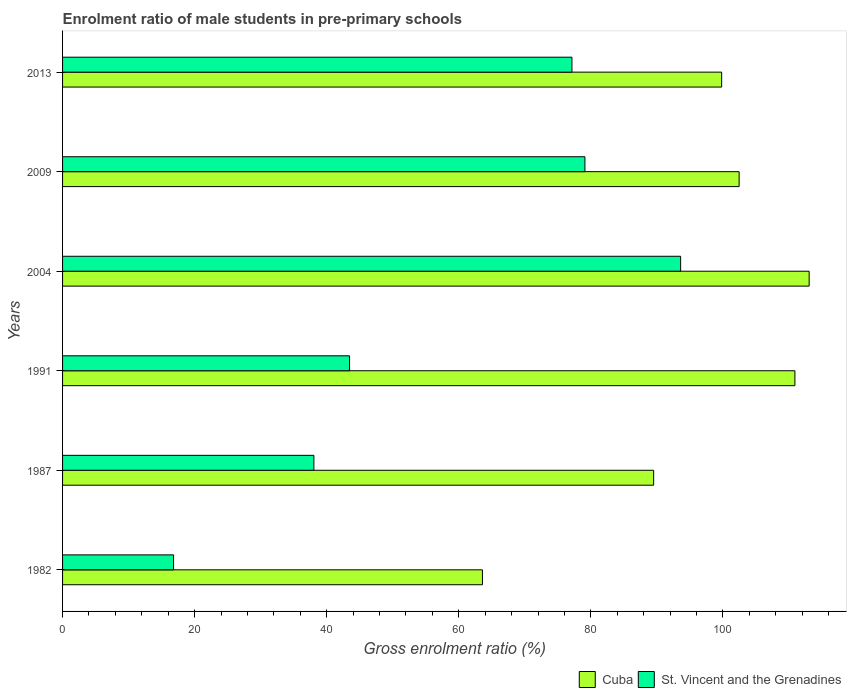How many different coloured bars are there?
Your answer should be very brief. 2. Are the number of bars per tick equal to the number of legend labels?
Offer a very short reply. Yes. Are the number of bars on each tick of the Y-axis equal?
Make the answer very short. Yes. How many bars are there on the 5th tick from the bottom?
Ensure brevity in your answer.  2. What is the label of the 3rd group of bars from the top?
Your response must be concise. 2004. What is the enrolment ratio of male students in pre-primary schools in St. Vincent and the Grenadines in 2013?
Offer a very short reply. 77.13. Across all years, what is the maximum enrolment ratio of male students in pre-primary schools in Cuba?
Ensure brevity in your answer.  113.05. Across all years, what is the minimum enrolment ratio of male students in pre-primary schools in St. Vincent and the Grenadines?
Offer a terse response. 16.81. What is the total enrolment ratio of male students in pre-primary schools in Cuba in the graph?
Give a very brief answer. 579.28. What is the difference between the enrolment ratio of male students in pre-primary schools in Cuba in 1982 and that in 2013?
Your response must be concise. -36.22. What is the difference between the enrolment ratio of male students in pre-primary schools in Cuba in 1991 and the enrolment ratio of male students in pre-primary schools in St. Vincent and the Grenadines in 2013?
Make the answer very short. 33.76. What is the average enrolment ratio of male students in pre-primary schools in St. Vincent and the Grenadines per year?
Offer a terse response. 58.02. In the year 1987, what is the difference between the enrolment ratio of male students in pre-primary schools in Cuba and enrolment ratio of male students in pre-primary schools in St. Vincent and the Grenadines?
Keep it short and to the point. 51.45. In how many years, is the enrolment ratio of male students in pre-primary schools in St. Vincent and the Grenadines greater than 28 %?
Offer a terse response. 5. What is the ratio of the enrolment ratio of male students in pre-primary schools in St. Vincent and the Grenadines in 1991 to that in 2013?
Keep it short and to the point. 0.56. Is the enrolment ratio of male students in pre-primary schools in St. Vincent and the Grenadines in 2004 less than that in 2013?
Provide a short and direct response. No. What is the difference between the highest and the second highest enrolment ratio of male students in pre-primary schools in St. Vincent and the Grenadines?
Keep it short and to the point. 14.49. What is the difference between the highest and the lowest enrolment ratio of male students in pre-primary schools in Cuba?
Keep it short and to the point. 49.47. In how many years, is the enrolment ratio of male students in pre-primary schools in St. Vincent and the Grenadines greater than the average enrolment ratio of male students in pre-primary schools in St. Vincent and the Grenadines taken over all years?
Your response must be concise. 3. Is the sum of the enrolment ratio of male students in pre-primary schools in Cuba in 1982 and 2013 greater than the maximum enrolment ratio of male students in pre-primary schools in St. Vincent and the Grenadines across all years?
Ensure brevity in your answer.  Yes. What does the 1st bar from the top in 2004 represents?
Provide a succinct answer. St. Vincent and the Grenadines. What does the 1st bar from the bottom in 2004 represents?
Offer a terse response. Cuba. Are all the bars in the graph horizontal?
Ensure brevity in your answer.  Yes. How many years are there in the graph?
Your answer should be very brief. 6. Does the graph contain any zero values?
Make the answer very short. No. Where does the legend appear in the graph?
Ensure brevity in your answer.  Bottom right. How many legend labels are there?
Your answer should be compact. 2. How are the legend labels stacked?
Provide a succinct answer. Horizontal. What is the title of the graph?
Provide a short and direct response. Enrolment ratio of male students in pre-primary schools. Does "United Arab Emirates" appear as one of the legend labels in the graph?
Your answer should be compact. No. What is the Gross enrolment ratio (%) of Cuba in 1982?
Offer a very short reply. 63.58. What is the Gross enrolment ratio (%) of St. Vincent and the Grenadines in 1982?
Ensure brevity in your answer.  16.81. What is the Gross enrolment ratio (%) of Cuba in 1987?
Offer a very short reply. 89.51. What is the Gross enrolment ratio (%) of St. Vincent and the Grenadines in 1987?
Give a very brief answer. 38.06. What is the Gross enrolment ratio (%) of Cuba in 1991?
Your answer should be compact. 110.89. What is the Gross enrolment ratio (%) in St. Vincent and the Grenadines in 1991?
Your answer should be very brief. 43.46. What is the Gross enrolment ratio (%) of Cuba in 2004?
Your response must be concise. 113.05. What is the Gross enrolment ratio (%) of St. Vincent and the Grenadines in 2004?
Your response must be concise. 93.59. What is the Gross enrolment ratio (%) of Cuba in 2009?
Offer a terse response. 102.45. What is the Gross enrolment ratio (%) in St. Vincent and the Grenadines in 2009?
Your response must be concise. 79.1. What is the Gross enrolment ratio (%) of Cuba in 2013?
Keep it short and to the point. 99.8. What is the Gross enrolment ratio (%) of St. Vincent and the Grenadines in 2013?
Provide a short and direct response. 77.13. Across all years, what is the maximum Gross enrolment ratio (%) in Cuba?
Your response must be concise. 113.05. Across all years, what is the maximum Gross enrolment ratio (%) in St. Vincent and the Grenadines?
Your answer should be compact. 93.59. Across all years, what is the minimum Gross enrolment ratio (%) in Cuba?
Provide a short and direct response. 63.58. Across all years, what is the minimum Gross enrolment ratio (%) of St. Vincent and the Grenadines?
Provide a succinct answer. 16.81. What is the total Gross enrolment ratio (%) in Cuba in the graph?
Offer a very short reply. 579.28. What is the total Gross enrolment ratio (%) in St. Vincent and the Grenadines in the graph?
Provide a succinct answer. 348.14. What is the difference between the Gross enrolment ratio (%) in Cuba in 1982 and that in 1987?
Provide a short and direct response. -25.93. What is the difference between the Gross enrolment ratio (%) in St. Vincent and the Grenadines in 1982 and that in 1987?
Ensure brevity in your answer.  -21.25. What is the difference between the Gross enrolment ratio (%) of Cuba in 1982 and that in 1991?
Make the answer very short. -47.31. What is the difference between the Gross enrolment ratio (%) in St. Vincent and the Grenadines in 1982 and that in 1991?
Keep it short and to the point. -26.65. What is the difference between the Gross enrolment ratio (%) in Cuba in 1982 and that in 2004?
Provide a short and direct response. -49.47. What is the difference between the Gross enrolment ratio (%) of St. Vincent and the Grenadines in 1982 and that in 2004?
Make the answer very short. -76.78. What is the difference between the Gross enrolment ratio (%) in Cuba in 1982 and that in 2009?
Your response must be concise. -38.87. What is the difference between the Gross enrolment ratio (%) of St. Vincent and the Grenadines in 1982 and that in 2009?
Offer a very short reply. -62.29. What is the difference between the Gross enrolment ratio (%) in Cuba in 1982 and that in 2013?
Your answer should be very brief. -36.22. What is the difference between the Gross enrolment ratio (%) in St. Vincent and the Grenadines in 1982 and that in 2013?
Your response must be concise. -60.32. What is the difference between the Gross enrolment ratio (%) of Cuba in 1987 and that in 1991?
Provide a short and direct response. -21.39. What is the difference between the Gross enrolment ratio (%) in St. Vincent and the Grenadines in 1987 and that in 1991?
Offer a terse response. -5.4. What is the difference between the Gross enrolment ratio (%) in Cuba in 1987 and that in 2004?
Your answer should be very brief. -23.55. What is the difference between the Gross enrolment ratio (%) in St. Vincent and the Grenadines in 1987 and that in 2004?
Ensure brevity in your answer.  -55.53. What is the difference between the Gross enrolment ratio (%) of Cuba in 1987 and that in 2009?
Ensure brevity in your answer.  -12.94. What is the difference between the Gross enrolment ratio (%) of St. Vincent and the Grenadines in 1987 and that in 2009?
Provide a short and direct response. -41.04. What is the difference between the Gross enrolment ratio (%) of Cuba in 1987 and that in 2013?
Offer a terse response. -10.3. What is the difference between the Gross enrolment ratio (%) of St. Vincent and the Grenadines in 1987 and that in 2013?
Keep it short and to the point. -39.07. What is the difference between the Gross enrolment ratio (%) of Cuba in 1991 and that in 2004?
Your response must be concise. -2.16. What is the difference between the Gross enrolment ratio (%) of St. Vincent and the Grenadines in 1991 and that in 2004?
Keep it short and to the point. -50.13. What is the difference between the Gross enrolment ratio (%) in Cuba in 1991 and that in 2009?
Provide a succinct answer. 8.45. What is the difference between the Gross enrolment ratio (%) of St. Vincent and the Grenadines in 1991 and that in 2009?
Offer a terse response. -35.64. What is the difference between the Gross enrolment ratio (%) in Cuba in 1991 and that in 2013?
Your answer should be very brief. 11.09. What is the difference between the Gross enrolment ratio (%) of St. Vincent and the Grenadines in 1991 and that in 2013?
Give a very brief answer. -33.67. What is the difference between the Gross enrolment ratio (%) in Cuba in 2004 and that in 2009?
Keep it short and to the point. 10.61. What is the difference between the Gross enrolment ratio (%) of St. Vincent and the Grenadines in 2004 and that in 2009?
Offer a very short reply. 14.49. What is the difference between the Gross enrolment ratio (%) in Cuba in 2004 and that in 2013?
Give a very brief answer. 13.25. What is the difference between the Gross enrolment ratio (%) in St. Vincent and the Grenadines in 2004 and that in 2013?
Offer a very short reply. 16.46. What is the difference between the Gross enrolment ratio (%) of Cuba in 2009 and that in 2013?
Ensure brevity in your answer.  2.65. What is the difference between the Gross enrolment ratio (%) of St. Vincent and the Grenadines in 2009 and that in 2013?
Your answer should be compact. 1.97. What is the difference between the Gross enrolment ratio (%) of Cuba in 1982 and the Gross enrolment ratio (%) of St. Vincent and the Grenadines in 1987?
Keep it short and to the point. 25.52. What is the difference between the Gross enrolment ratio (%) of Cuba in 1982 and the Gross enrolment ratio (%) of St. Vincent and the Grenadines in 1991?
Provide a short and direct response. 20.12. What is the difference between the Gross enrolment ratio (%) of Cuba in 1982 and the Gross enrolment ratio (%) of St. Vincent and the Grenadines in 2004?
Provide a short and direct response. -30.01. What is the difference between the Gross enrolment ratio (%) of Cuba in 1982 and the Gross enrolment ratio (%) of St. Vincent and the Grenadines in 2009?
Offer a terse response. -15.52. What is the difference between the Gross enrolment ratio (%) in Cuba in 1982 and the Gross enrolment ratio (%) in St. Vincent and the Grenadines in 2013?
Provide a short and direct response. -13.55. What is the difference between the Gross enrolment ratio (%) of Cuba in 1987 and the Gross enrolment ratio (%) of St. Vincent and the Grenadines in 1991?
Your answer should be compact. 46.05. What is the difference between the Gross enrolment ratio (%) of Cuba in 1987 and the Gross enrolment ratio (%) of St. Vincent and the Grenadines in 2004?
Keep it short and to the point. -4.08. What is the difference between the Gross enrolment ratio (%) in Cuba in 1987 and the Gross enrolment ratio (%) in St. Vincent and the Grenadines in 2009?
Keep it short and to the point. 10.41. What is the difference between the Gross enrolment ratio (%) in Cuba in 1987 and the Gross enrolment ratio (%) in St. Vincent and the Grenadines in 2013?
Your answer should be compact. 12.37. What is the difference between the Gross enrolment ratio (%) of Cuba in 1991 and the Gross enrolment ratio (%) of St. Vincent and the Grenadines in 2004?
Give a very brief answer. 17.3. What is the difference between the Gross enrolment ratio (%) in Cuba in 1991 and the Gross enrolment ratio (%) in St. Vincent and the Grenadines in 2009?
Provide a short and direct response. 31.8. What is the difference between the Gross enrolment ratio (%) of Cuba in 1991 and the Gross enrolment ratio (%) of St. Vincent and the Grenadines in 2013?
Offer a terse response. 33.76. What is the difference between the Gross enrolment ratio (%) in Cuba in 2004 and the Gross enrolment ratio (%) in St. Vincent and the Grenadines in 2009?
Offer a very short reply. 33.96. What is the difference between the Gross enrolment ratio (%) of Cuba in 2004 and the Gross enrolment ratio (%) of St. Vincent and the Grenadines in 2013?
Offer a terse response. 35.92. What is the difference between the Gross enrolment ratio (%) of Cuba in 2009 and the Gross enrolment ratio (%) of St. Vincent and the Grenadines in 2013?
Offer a very short reply. 25.32. What is the average Gross enrolment ratio (%) of Cuba per year?
Ensure brevity in your answer.  96.55. What is the average Gross enrolment ratio (%) of St. Vincent and the Grenadines per year?
Make the answer very short. 58.02. In the year 1982, what is the difference between the Gross enrolment ratio (%) in Cuba and Gross enrolment ratio (%) in St. Vincent and the Grenadines?
Keep it short and to the point. 46.77. In the year 1987, what is the difference between the Gross enrolment ratio (%) of Cuba and Gross enrolment ratio (%) of St. Vincent and the Grenadines?
Provide a short and direct response. 51.45. In the year 1991, what is the difference between the Gross enrolment ratio (%) of Cuba and Gross enrolment ratio (%) of St. Vincent and the Grenadines?
Give a very brief answer. 67.44. In the year 2004, what is the difference between the Gross enrolment ratio (%) of Cuba and Gross enrolment ratio (%) of St. Vincent and the Grenadines?
Offer a very short reply. 19.46. In the year 2009, what is the difference between the Gross enrolment ratio (%) of Cuba and Gross enrolment ratio (%) of St. Vincent and the Grenadines?
Make the answer very short. 23.35. In the year 2013, what is the difference between the Gross enrolment ratio (%) of Cuba and Gross enrolment ratio (%) of St. Vincent and the Grenadines?
Your answer should be compact. 22.67. What is the ratio of the Gross enrolment ratio (%) in Cuba in 1982 to that in 1987?
Provide a short and direct response. 0.71. What is the ratio of the Gross enrolment ratio (%) of St. Vincent and the Grenadines in 1982 to that in 1987?
Give a very brief answer. 0.44. What is the ratio of the Gross enrolment ratio (%) in Cuba in 1982 to that in 1991?
Your answer should be compact. 0.57. What is the ratio of the Gross enrolment ratio (%) in St. Vincent and the Grenadines in 1982 to that in 1991?
Provide a short and direct response. 0.39. What is the ratio of the Gross enrolment ratio (%) in Cuba in 1982 to that in 2004?
Your answer should be very brief. 0.56. What is the ratio of the Gross enrolment ratio (%) of St. Vincent and the Grenadines in 1982 to that in 2004?
Provide a succinct answer. 0.18. What is the ratio of the Gross enrolment ratio (%) of Cuba in 1982 to that in 2009?
Offer a very short reply. 0.62. What is the ratio of the Gross enrolment ratio (%) of St. Vincent and the Grenadines in 1982 to that in 2009?
Provide a succinct answer. 0.21. What is the ratio of the Gross enrolment ratio (%) of Cuba in 1982 to that in 2013?
Your answer should be compact. 0.64. What is the ratio of the Gross enrolment ratio (%) of St. Vincent and the Grenadines in 1982 to that in 2013?
Offer a terse response. 0.22. What is the ratio of the Gross enrolment ratio (%) of Cuba in 1987 to that in 1991?
Make the answer very short. 0.81. What is the ratio of the Gross enrolment ratio (%) of St. Vincent and the Grenadines in 1987 to that in 1991?
Ensure brevity in your answer.  0.88. What is the ratio of the Gross enrolment ratio (%) in Cuba in 1987 to that in 2004?
Make the answer very short. 0.79. What is the ratio of the Gross enrolment ratio (%) of St. Vincent and the Grenadines in 1987 to that in 2004?
Offer a terse response. 0.41. What is the ratio of the Gross enrolment ratio (%) of Cuba in 1987 to that in 2009?
Offer a terse response. 0.87. What is the ratio of the Gross enrolment ratio (%) of St. Vincent and the Grenadines in 1987 to that in 2009?
Provide a succinct answer. 0.48. What is the ratio of the Gross enrolment ratio (%) in Cuba in 1987 to that in 2013?
Your answer should be compact. 0.9. What is the ratio of the Gross enrolment ratio (%) in St. Vincent and the Grenadines in 1987 to that in 2013?
Provide a short and direct response. 0.49. What is the ratio of the Gross enrolment ratio (%) in Cuba in 1991 to that in 2004?
Ensure brevity in your answer.  0.98. What is the ratio of the Gross enrolment ratio (%) of St. Vincent and the Grenadines in 1991 to that in 2004?
Give a very brief answer. 0.46. What is the ratio of the Gross enrolment ratio (%) in Cuba in 1991 to that in 2009?
Your answer should be very brief. 1.08. What is the ratio of the Gross enrolment ratio (%) of St. Vincent and the Grenadines in 1991 to that in 2009?
Make the answer very short. 0.55. What is the ratio of the Gross enrolment ratio (%) in Cuba in 1991 to that in 2013?
Keep it short and to the point. 1.11. What is the ratio of the Gross enrolment ratio (%) in St. Vincent and the Grenadines in 1991 to that in 2013?
Your answer should be very brief. 0.56. What is the ratio of the Gross enrolment ratio (%) of Cuba in 2004 to that in 2009?
Keep it short and to the point. 1.1. What is the ratio of the Gross enrolment ratio (%) in St. Vincent and the Grenadines in 2004 to that in 2009?
Provide a short and direct response. 1.18. What is the ratio of the Gross enrolment ratio (%) in Cuba in 2004 to that in 2013?
Keep it short and to the point. 1.13. What is the ratio of the Gross enrolment ratio (%) of St. Vincent and the Grenadines in 2004 to that in 2013?
Provide a short and direct response. 1.21. What is the ratio of the Gross enrolment ratio (%) in Cuba in 2009 to that in 2013?
Ensure brevity in your answer.  1.03. What is the ratio of the Gross enrolment ratio (%) of St. Vincent and the Grenadines in 2009 to that in 2013?
Provide a short and direct response. 1.03. What is the difference between the highest and the second highest Gross enrolment ratio (%) in Cuba?
Your response must be concise. 2.16. What is the difference between the highest and the second highest Gross enrolment ratio (%) of St. Vincent and the Grenadines?
Keep it short and to the point. 14.49. What is the difference between the highest and the lowest Gross enrolment ratio (%) of Cuba?
Your response must be concise. 49.47. What is the difference between the highest and the lowest Gross enrolment ratio (%) in St. Vincent and the Grenadines?
Your response must be concise. 76.78. 